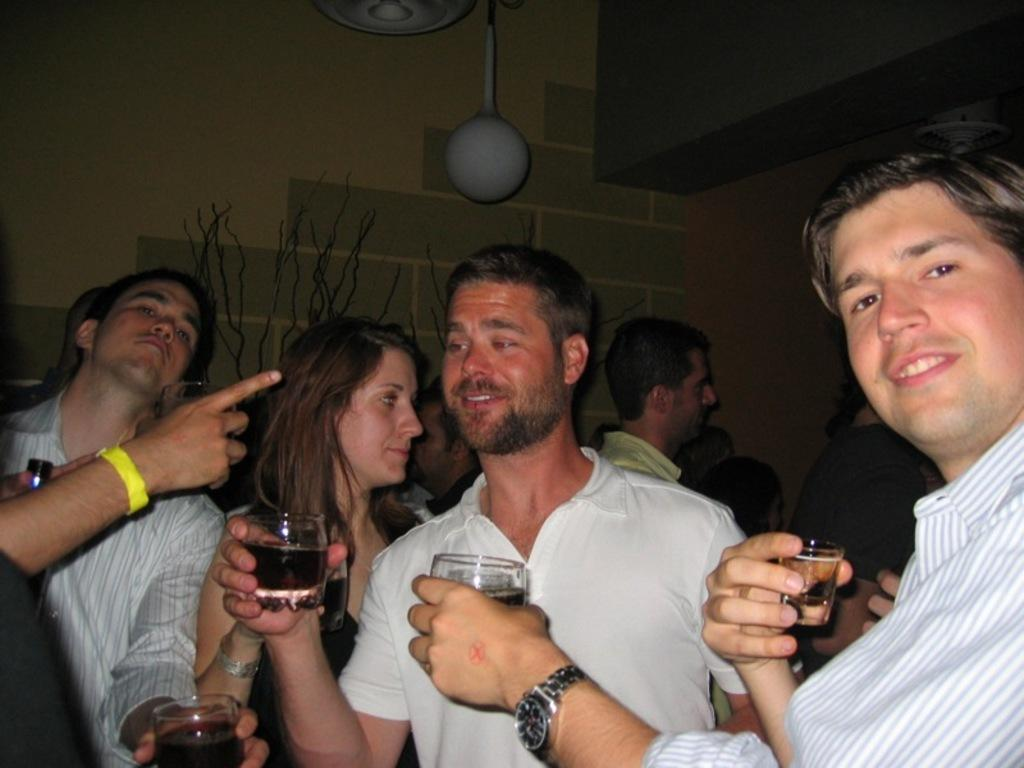Who or what can be seen in the image? There are people in the image. What are some of the people holding in the image? Some people are holding glasses with drinks. What can be seen in the background of the image? There are decorative objects and a wall visible in the background of the image. How does the adjustment of the sail affect the driving in the image? There is no sail or driving present in the image; it features people holding glasses with drinks and a background with decorative objects and a wall. 